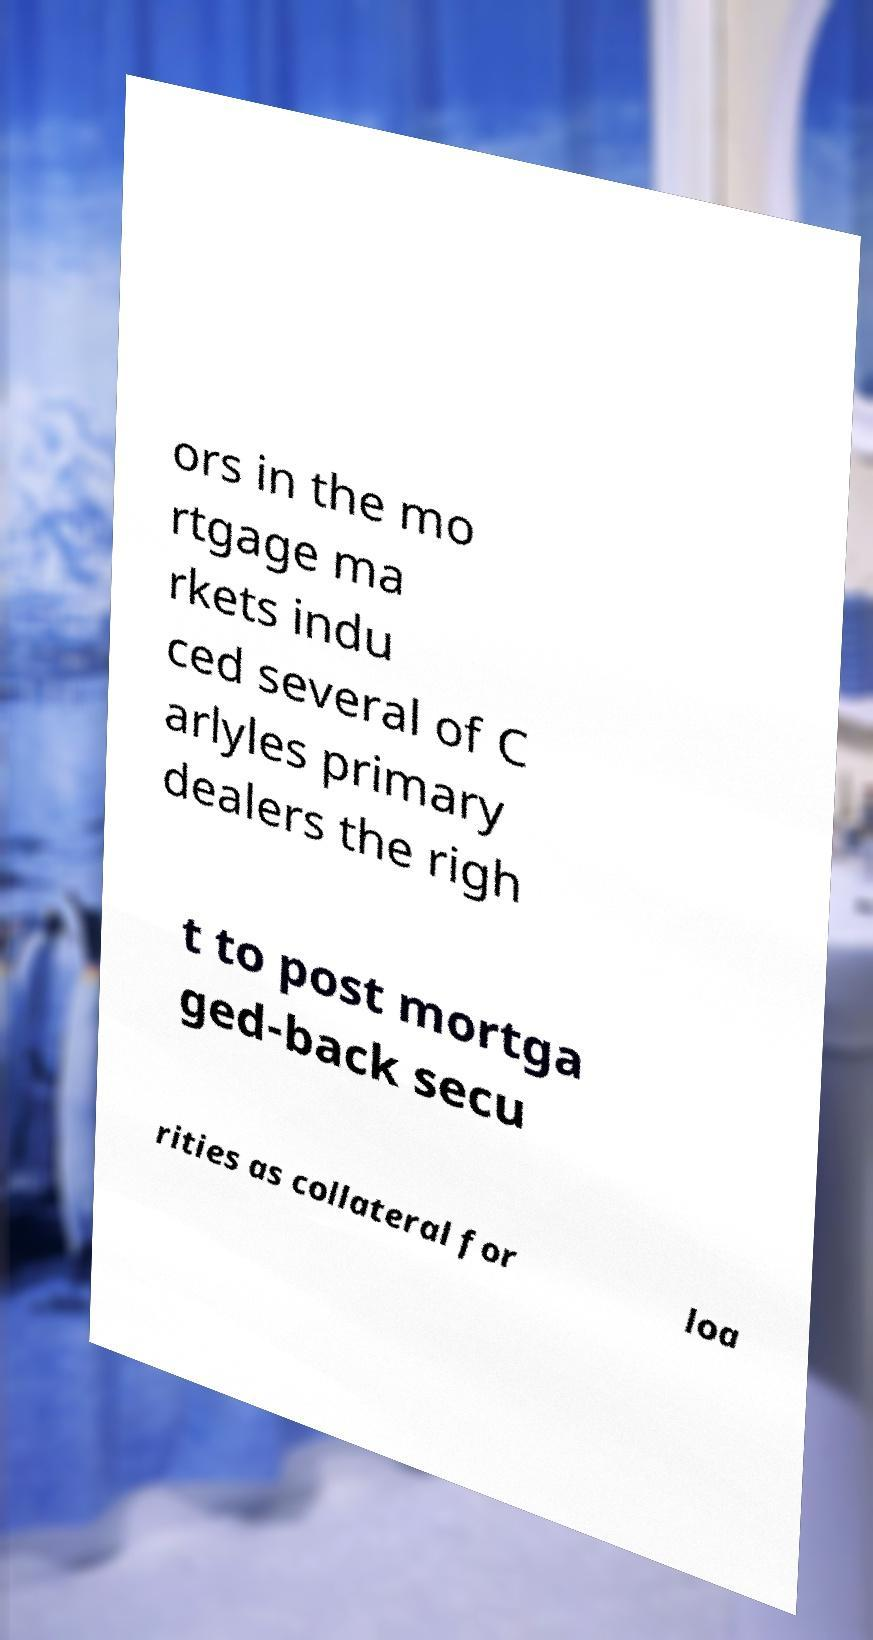Can you read and provide the text displayed in the image?This photo seems to have some interesting text. Can you extract and type it out for me? ors in the mo rtgage ma rkets indu ced several of C arlyles primary dealers the righ t to post mortga ged-back secu rities as collateral for loa 